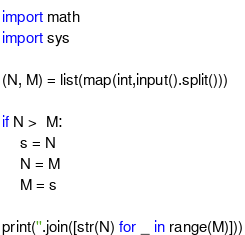Convert code to text. <code><loc_0><loc_0><loc_500><loc_500><_Python_>import math
import sys

(N, M) = list(map(int,input().split()))

if N >  M:
    s = N
    N = M
    M = s 

print(''.join([str(N) for _ in range(M)]))
</code> 